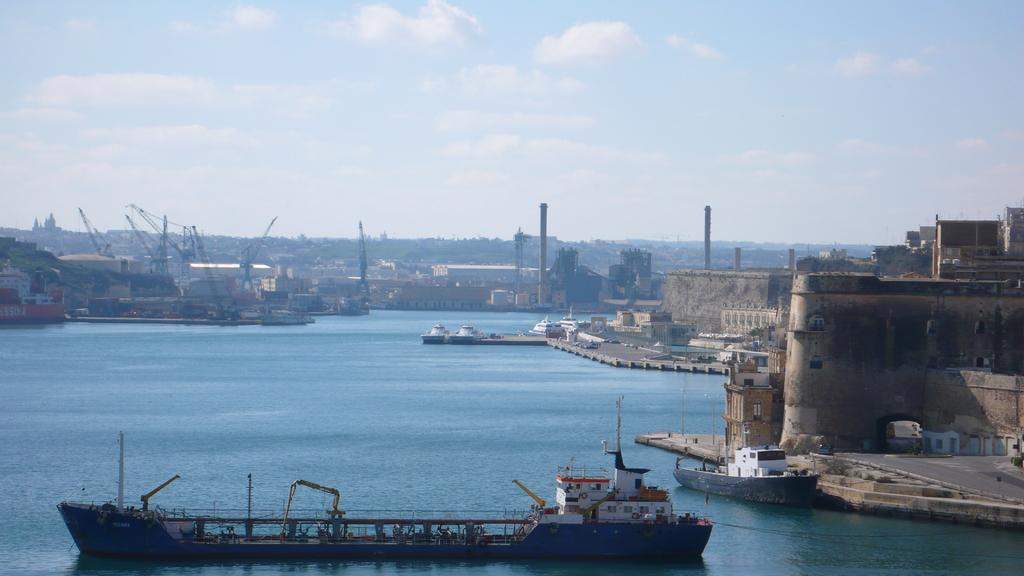What type of vehicles are in the image? There are boats in the image. What is at the bottom of the image? There is water at the bottom of the image. What is to the right of the image? There is a wall to the right of the image. What is visible in the sky at the top of the image? There are clouds in the sky at the top of the image. Can you see any quicksand in the image? There is no quicksand present in the image. How many people are jumping into the water from the boats? There is no indication of people jumping into the water from the boats in the image. 